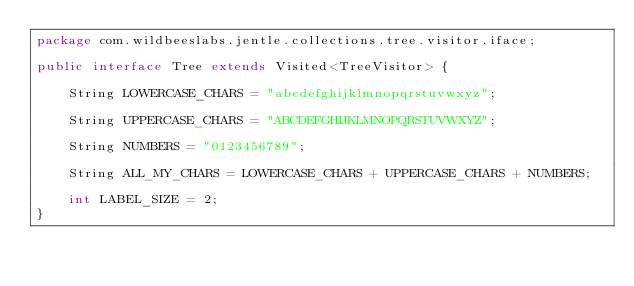Convert code to text. <code><loc_0><loc_0><loc_500><loc_500><_Java_>package com.wildbeeslabs.jentle.collections.tree.visitor.iface;

public interface Tree extends Visited<TreeVisitor> {

    String LOWERCASE_CHARS = "abcdefghijklmnopqrstuvwxyz";

    String UPPERCASE_CHARS = "ABCDEFGHIJKLMNOPQRSTUVWXYZ";

    String NUMBERS = "0123456789";

    String ALL_MY_CHARS = LOWERCASE_CHARS + UPPERCASE_CHARS + NUMBERS;

    int LABEL_SIZE = 2;
}
</code> 